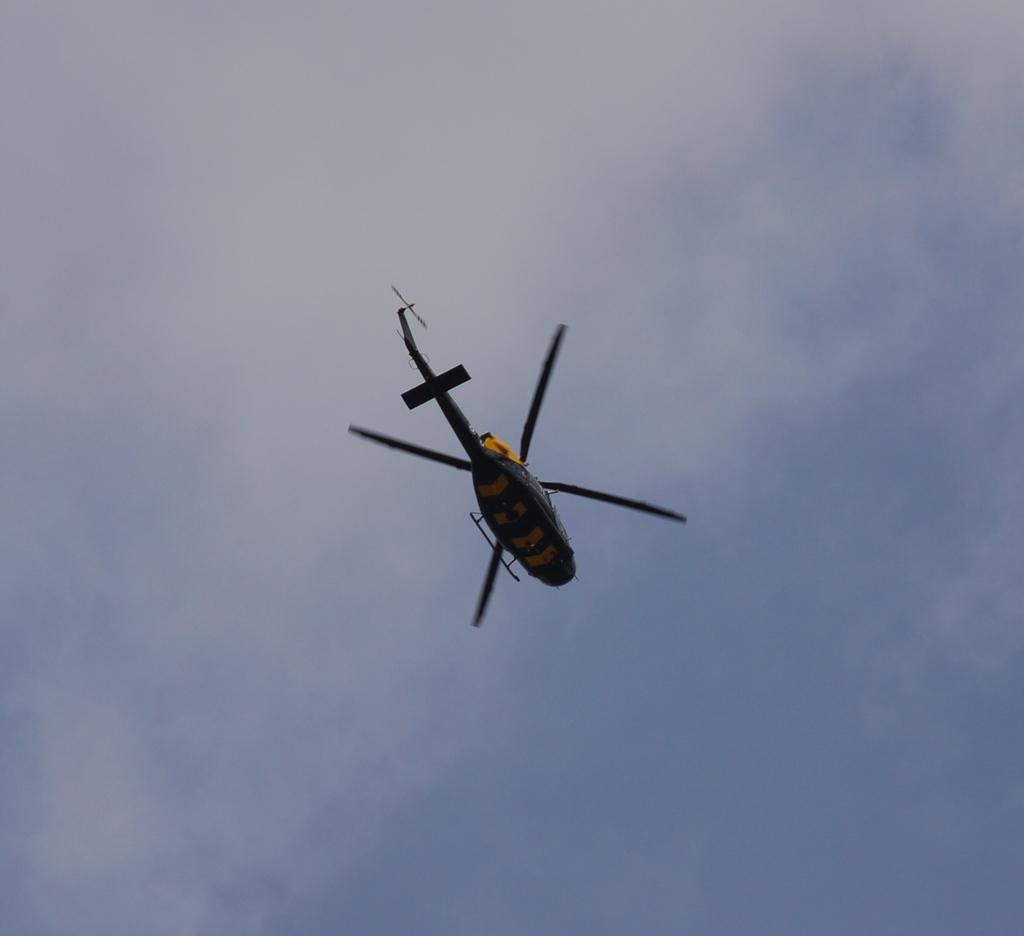What is the main subject of the image? The main subject of the image is a helicopter. What is the helicopter doing in the image? The helicopter is flying in the air. What can be seen in the background of the image? The sky and clouds are visible in the background of the image. What type of fowl can be seen perched on the helicopter in the image? There are no fowl present on the helicopter in the image. What material is the brass used for in the image? There is no brass present in the image. 